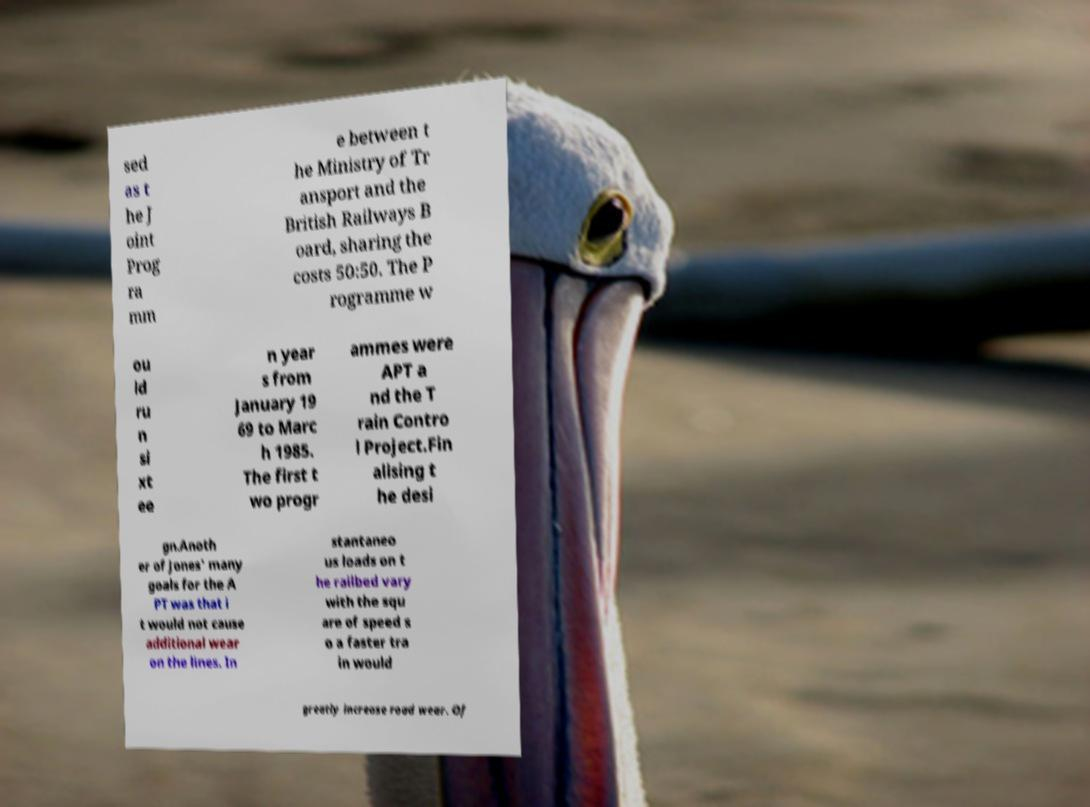Could you assist in decoding the text presented in this image and type it out clearly? sed as t he J oint Prog ra mm e between t he Ministry of Tr ansport and the British Railways B oard, sharing the costs 50:50. The P rogramme w ou ld ru n si xt ee n year s from January 19 69 to Marc h 1985. The first t wo progr ammes were APT a nd the T rain Contro l Project.Fin alising t he desi gn.Anoth er of Jones' many goals for the A PT was that i t would not cause additional wear on the lines. In stantaneo us loads on t he railbed vary with the squ are of speed s o a faster tra in would greatly increase road wear. Of 